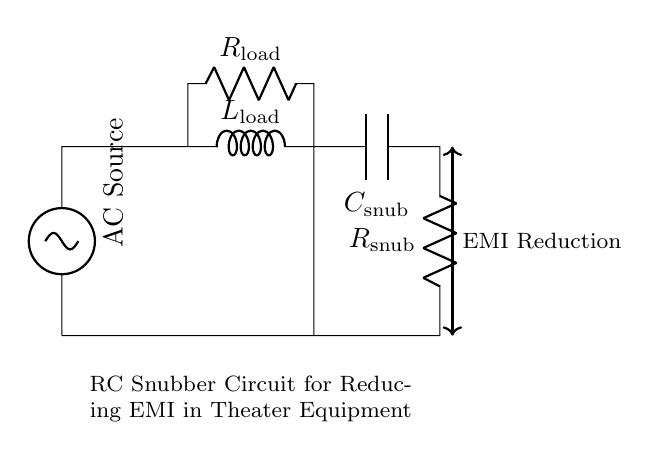What does "R" represent in this circuit? "R" represents the resistor used in the RC snubber circuit, specifically denoting the resistance value for reducing EMI.
Answer: resistor What does "C" signify in the circuit diagram? "C" signifies the capacitor in the RC snubber circuit, which serves to absorb and release energy, helping to filter out high-frequency noise.
Answer: capacitor What is the role of the "AC Source" in this setup? The "AC Source" provides the alternating current needed to power the circuit and is a source for the electromagnetic interference that the snubber seeks to mitigate.
Answer: power source How is electromagnetic interference reduced in this circuit? Electromagnetic interference is reduced through the combined action of the resistor and capacitor, which dampens voltage spikes and smoothes out the waveform.
Answer: RC components What is connected in series with the "Load"? The load, indicated as "L," is connected in series with the additional resistor “R load," which represents the load resistance in the overall circuit.
Answer: load resistor What type of circuit is shown in this diagram? The diagram depicts an RC snubber circuit, specifically designed for reducing EMI, utilizing both a resistor and capacitor.
Answer: RC snubber circuit What is the function of the capacitor in an RC snubber? The capacitor in the snubber circuit functions to absorb transient voltage spikes, thereby protecting sensitive electronic components from potential damage due to EMI.
Answer: voltage spike absorption 